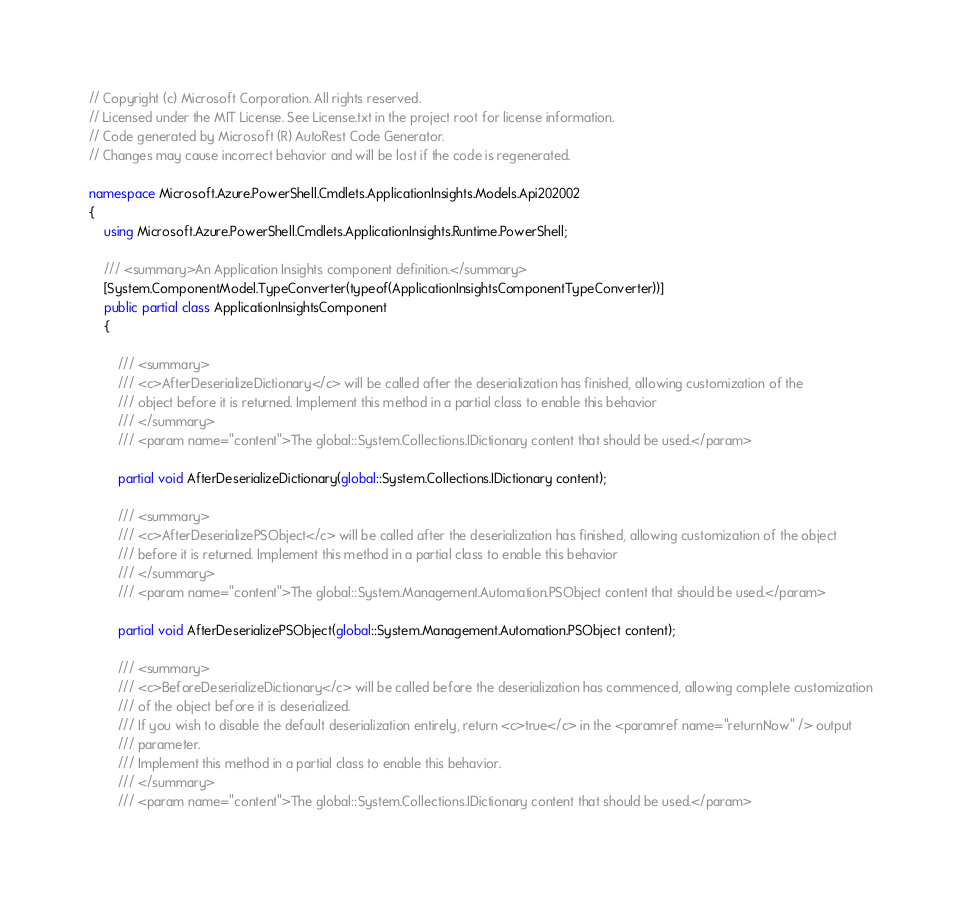Convert code to text. <code><loc_0><loc_0><loc_500><loc_500><_C#_>// Copyright (c) Microsoft Corporation. All rights reserved.
// Licensed under the MIT License. See License.txt in the project root for license information.
// Code generated by Microsoft (R) AutoRest Code Generator.
// Changes may cause incorrect behavior and will be lost if the code is regenerated.

namespace Microsoft.Azure.PowerShell.Cmdlets.ApplicationInsights.Models.Api202002
{
    using Microsoft.Azure.PowerShell.Cmdlets.ApplicationInsights.Runtime.PowerShell;

    /// <summary>An Application Insights component definition.</summary>
    [System.ComponentModel.TypeConverter(typeof(ApplicationInsightsComponentTypeConverter))]
    public partial class ApplicationInsightsComponent
    {

        /// <summary>
        /// <c>AfterDeserializeDictionary</c> will be called after the deserialization has finished, allowing customization of the
        /// object before it is returned. Implement this method in a partial class to enable this behavior
        /// </summary>
        /// <param name="content">The global::System.Collections.IDictionary content that should be used.</param>

        partial void AfterDeserializeDictionary(global::System.Collections.IDictionary content);

        /// <summary>
        /// <c>AfterDeserializePSObject</c> will be called after the deserialization has finished, allowing customization of the object
        /// before it is returned. Implement this method in a partial class to enable this behavior
        /// </summary>
        /// <param name="content">The global::System.Management.Automation.PSObject content that should be used.</param>

        partial void AfterDeserializePSObject(global::System.Management.Automation.PSObject content);

        /// <summary>
        /// <c>BeforeDeserializeDictionary</c> will be called before the deserialization has commenced, allowing complete customization
        /// of the object before it is deserialized.
        /// If you wish to disable the default deserialization entirely, return <c>true</c> in the <paramref name="returnNow" /> output
        /// parameter.
        /// Implement this method in a partial class to enable this behavior.
        /// </summary>
        /// <param name="content">The global::System.Collections.IDictionary content that should be used.</param></code> 